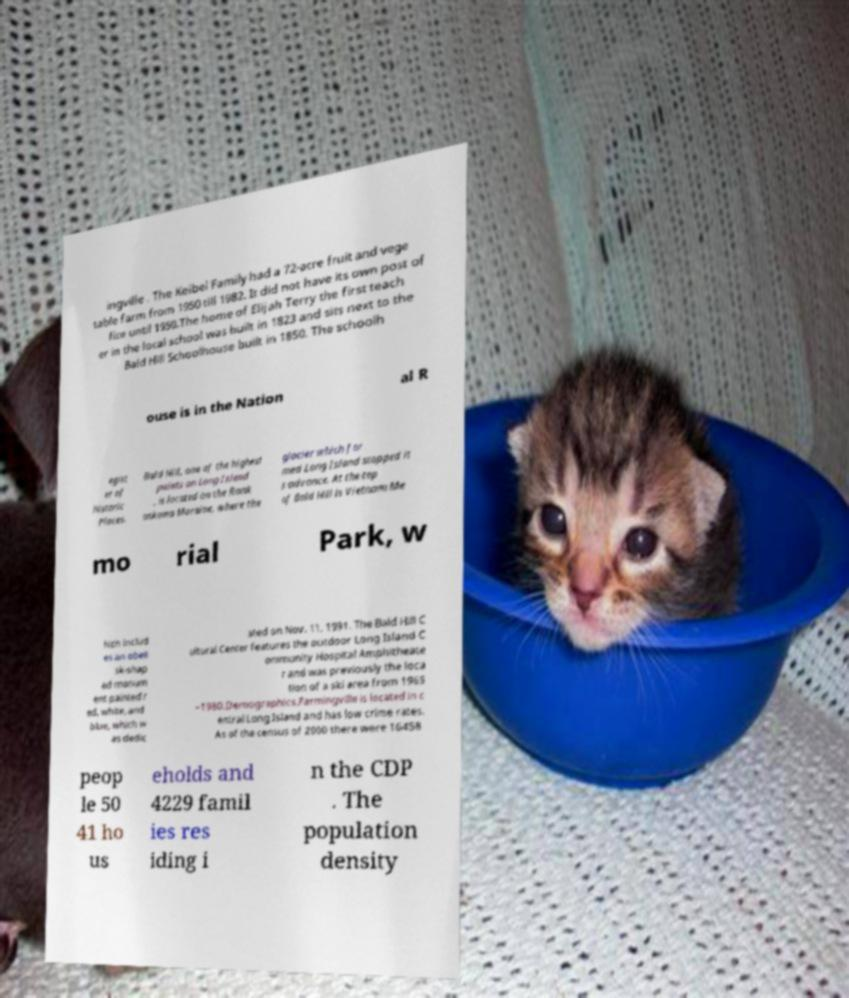For documentation purposes, I need the text within this image transcribed. Could you provide that? ingville . The Keibel Family had a 72-acre fruit and vege table farm from 1950 till 1982. It did not have its own post of fice until 1950.The home of Elijah Terry the first teach er in the local school was built in 1823 and sits next to the Bald Hill Schoolhouse built in 1850. The schoolh ouse is in the Nation al R egist er of Historic Places. Bald Hill, one of the highest points on Long Island , is located on the Ronk onkoma Moraine, where the glacier which for med Long Island stopped it s advance. At the top of Bald Hill is Vietnam Me mo rial Park, w hich includ es an obeli sk-shap ed monum ent painted r ed, white, and blue, which w as dedic ated on Nov. 11, 1991. The Bald Hill C ultural Center features the outdoor Long Island C ommunity Hospital Amphitheate r and was previously the loca tion of a ski area from 1965 –1980.Demographics.Farmingville is located in c entral Long Island and has low crime rates. As of the census of 2000 there were 16458 peop le 50 41 ho us eholds and 4229 famil ies res iding i n the CDP . The population density 